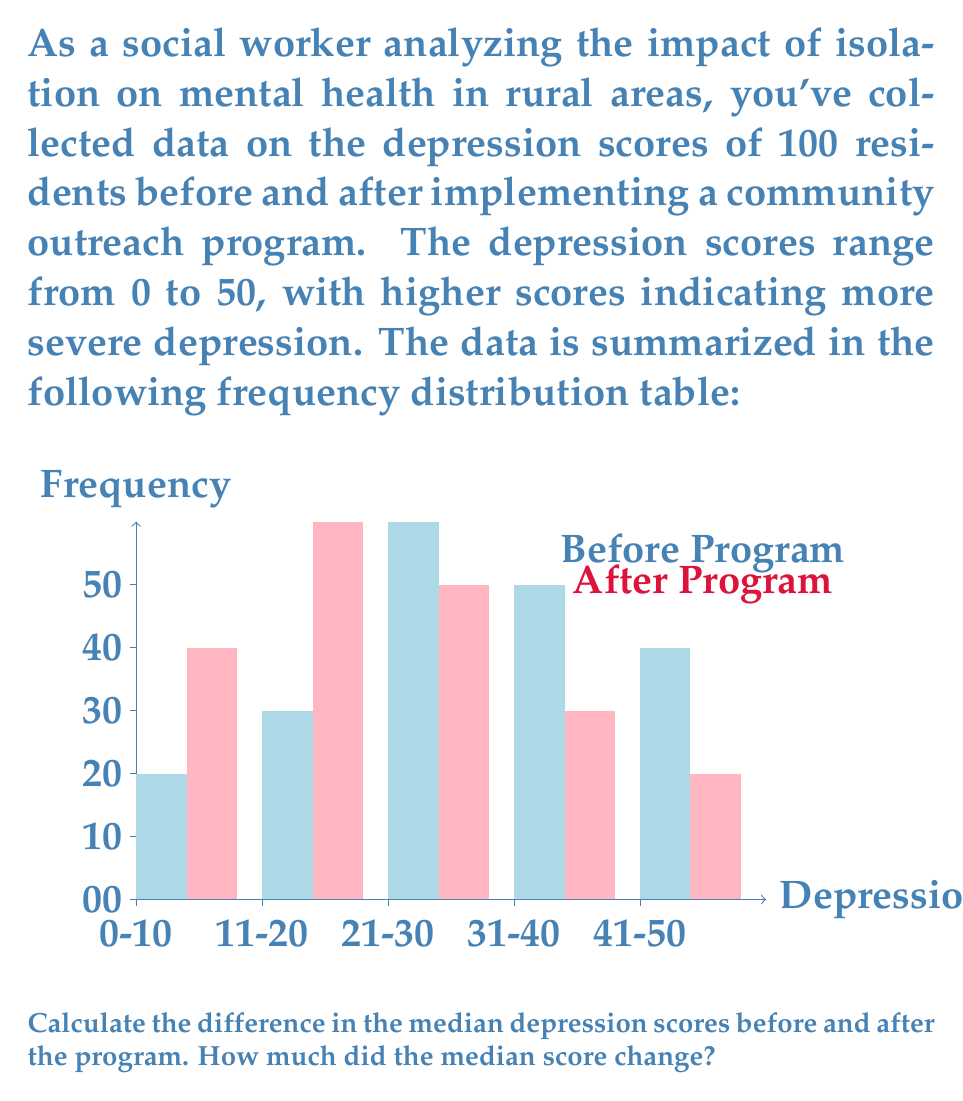Can you answer this question? To solve this problem, we need to find the median depression score before and after the program, then calculate the difference. Let's approach this step-by-step:

1. Find the median before the program:
   - Total participants: 100
   - Median position: (100 + 1) / 2 = 50.5th position
   - Cumulative frequencies:
     0-10: 10
     11-20: 10 + 15 = 25
     21-30: 25 + 30 = 55 (contains median)
   - The median lies in the 21-30 range
   - Interpolation: $20 + \frac{50.5 - 25}{30} \times 10 = 28.5$

2. Find the median after the program:
   - Total participants: 100
   - Median position: 50.5th position
   - Cumulative frequencies:
     0-10: 20
     11-20: 20 + 30 = 50 (contains median)
   - The median lies in the 11-20 range
   - Interpolation: $10 + \frac{50.5 - 20}{30} \times 10 = 20.17$

3. Calculate the difference:
   Difference = Median before - Median after
               = 28.5 - 20.17
               = 8.33

The median depression score decreased by 8.33 points after the program.
Answer: 8.33 